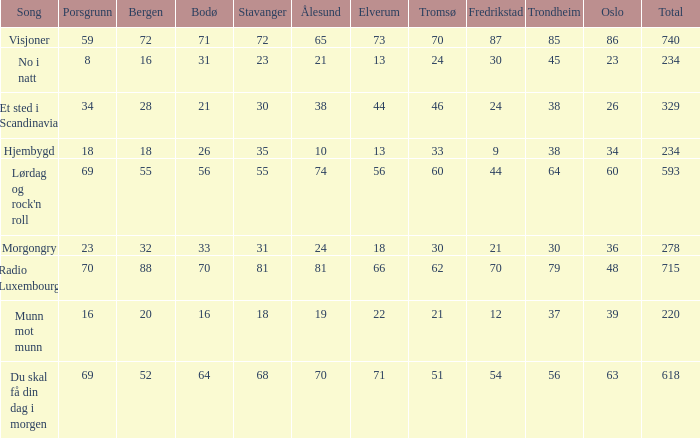What is the lowest total? 220.0. 